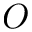<formula> <loc_0><loc_0><loc_500><loc_500>O</formula> 